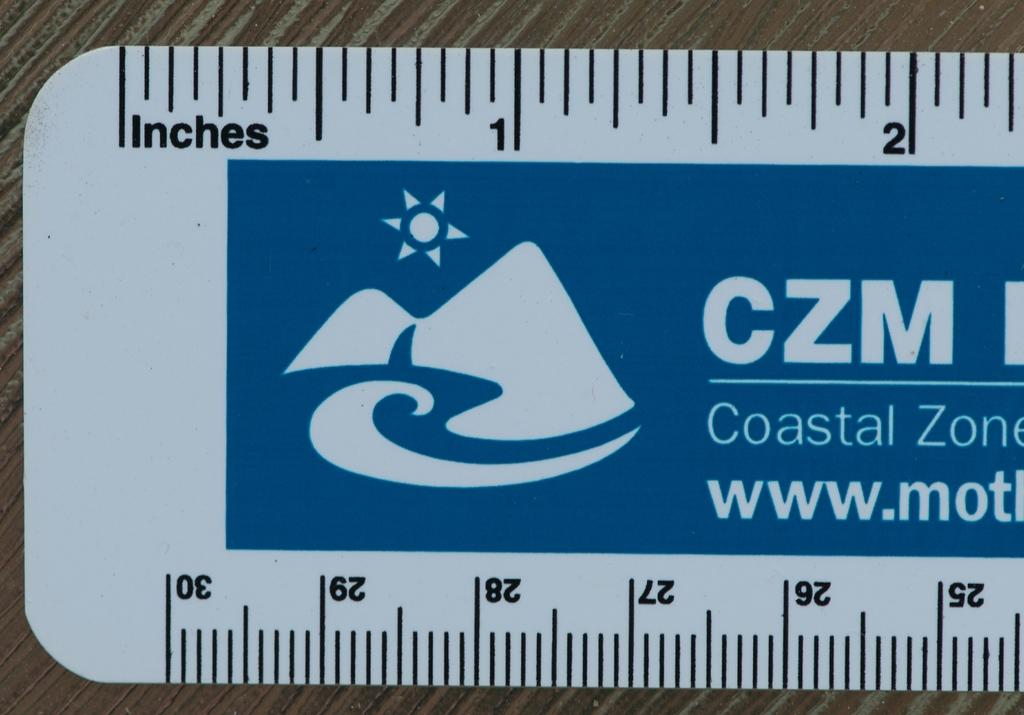<image>
Summarize the visual content of the image. A white ruler says Coastal Zone and measures in inches. 